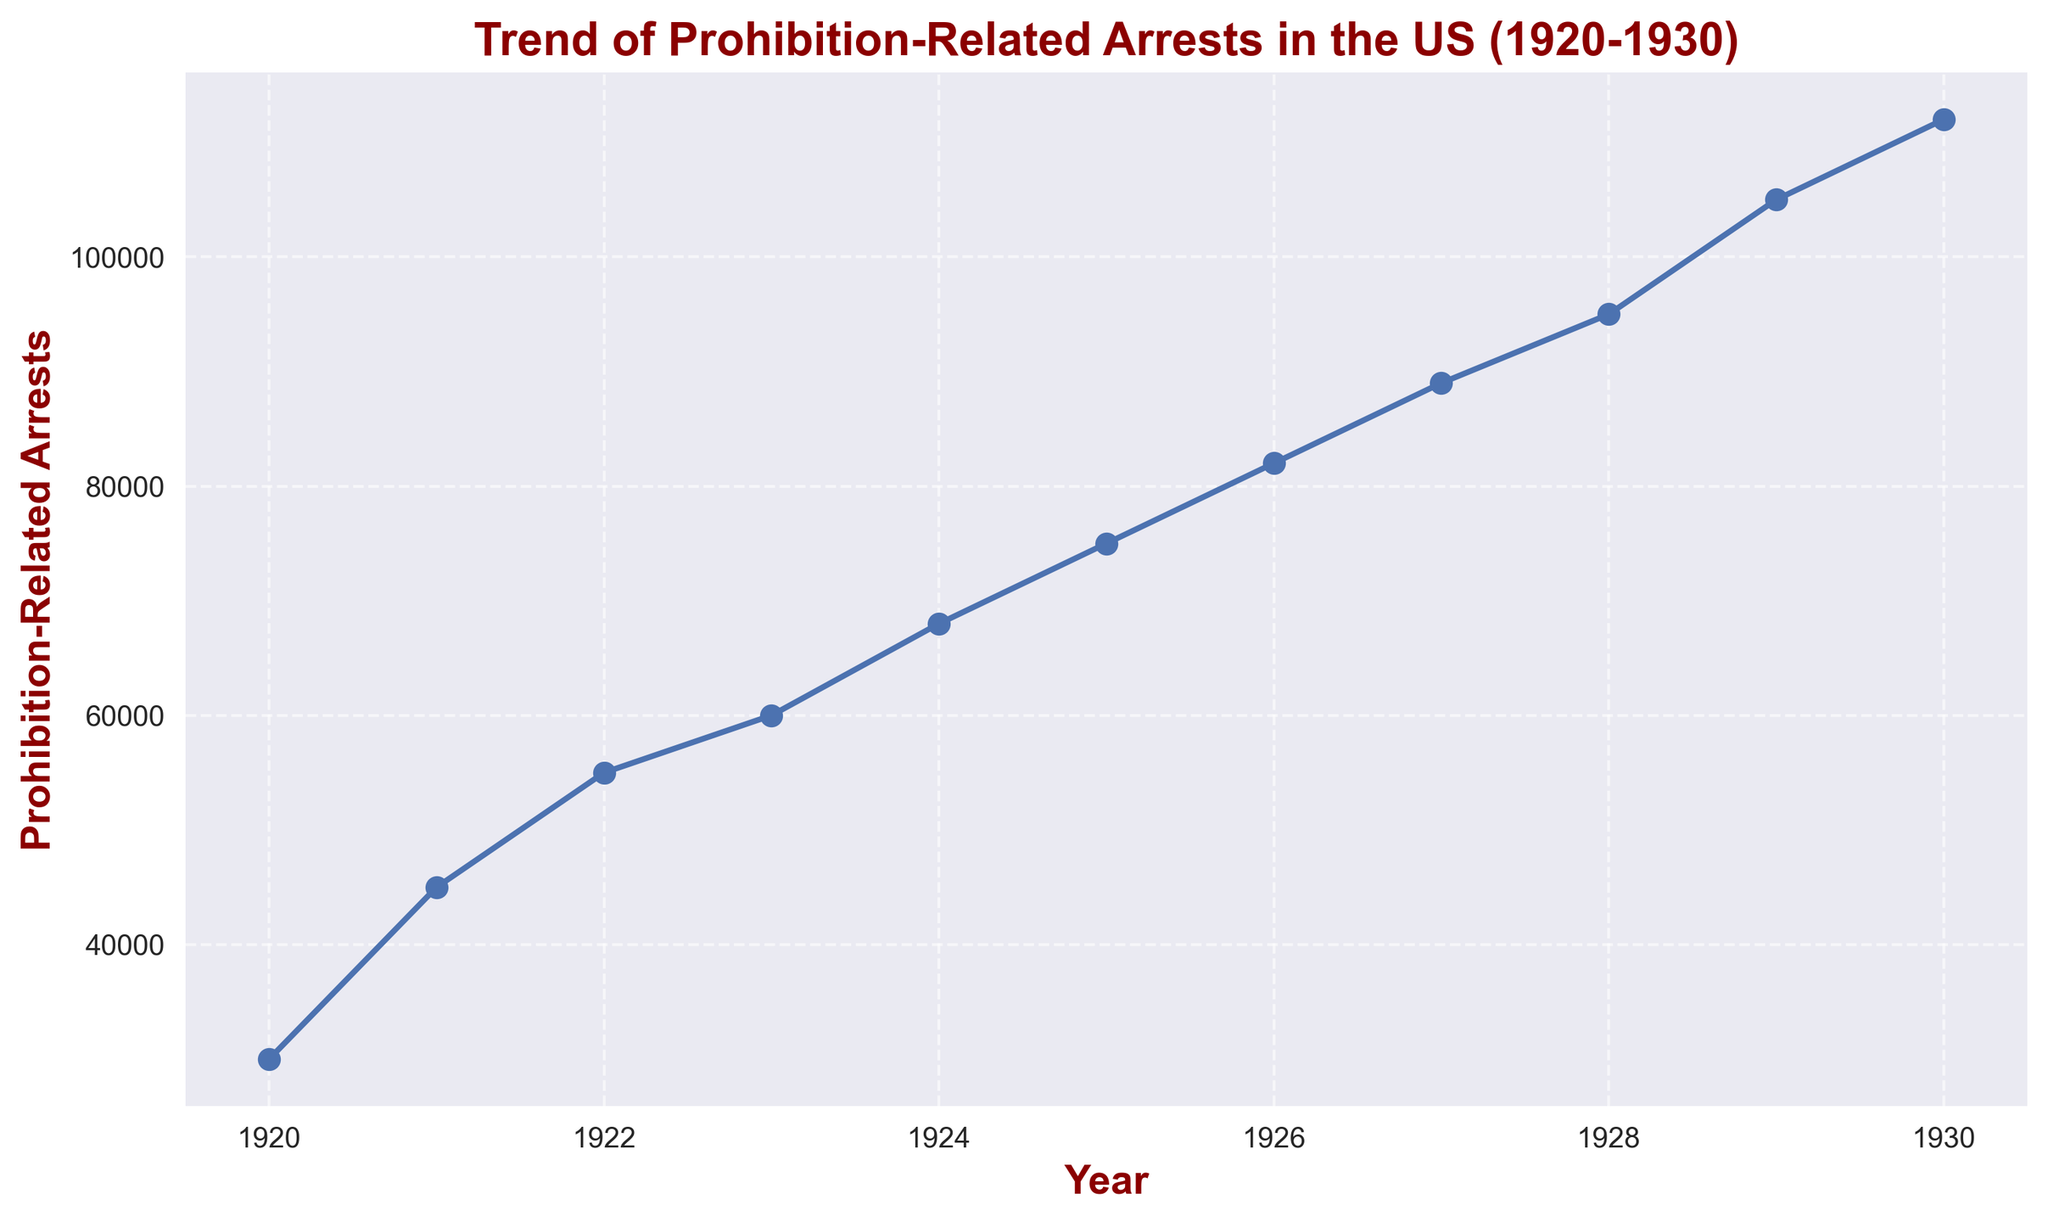Which year had the highest number of Prohibition-related arrests in the 1920s? We observe from the chart that the curve peaks at 1930 indicating the highest value.
Answer: 1930 How did the number of Prohibition-related arrests change from 1920 to 1930? By observing the trend line, we can see a steady increase from 30,000 arrests in 1920 to 112,000 arrests in 1930.
Answer: Increased by 82,000 Compare the number of Prohibition-related arrests in 1924 and 1926. Which year had higher arrests and by how much? Looking at the graph, we see that in 1924 there were 68,000 arrests and in 1926 there were 82,000 arrests. The difference is 82,000 - 68,000 = 14,000.
Answer: 1926, by 14,000 What was the average number of Prohibition-related arrests from 1920 to 1925? Sum the values from 1920 to 1925: (30,000 + 45,000 + 55,000 + 60,000 + 68,000 + 75,000) and divide by the number of years (6). This gives an average of (30,000 + 45,000 + 55,000 + 60,000 + 68,000 + 75,000) / 6 = 333,000 / 6 = 55,500.
Answer: 55,500 By how much did the number of arrests increase annually on average from 1920 to 1930? The increase from 1920 to 1930 is from 30,000 to 112,000, which is an increase of 82,000 over 10 years. The average annual increase is calculated by dividing the total increase by the number of years: 82,000 / 10 = 8,200.
Answer: 8,200 During which year did the most significant increase in arrests occur compared to the previous year? We compare the differences between consecutive years. The largest increase happened between 1928 (95,000) and 1929 (105,000), which is 105,000 - 95,000 = 10,000.
Answer: 1929 What color is used to plot the trend of Prohibition-related arrests? The trend line in the plot is colored blue.
Answer: Blue Calculate the total number of Prohibition-related arrests from 1920 to 1930. Sum all the values from 1920 to 1930: 30,000 + 45,000 + 55,000 + 60,000 + 68,000 + 75,000 + 82,000 + 89,000 + 95,000 + 105,000 + 112,000 = 816,000.
Answer: 816,000 Which year saw the smallest increase in Prohibition-related arrests compared to the previous year between 1920 and 1930? By subtracting each consecutive year's arrests, we find the smallest increase is between 1926 (82,000) and 1927 (89,000), which is 89,000 - 82,000 = 7,000.
Answer: 1927 What is the overall trend of the plot showing Prohibition-related arrests from 1920 to 1930? The overall trend is upward, indicating a steady increase in the number of arrests throughout the decade.
Answer: Increasing 